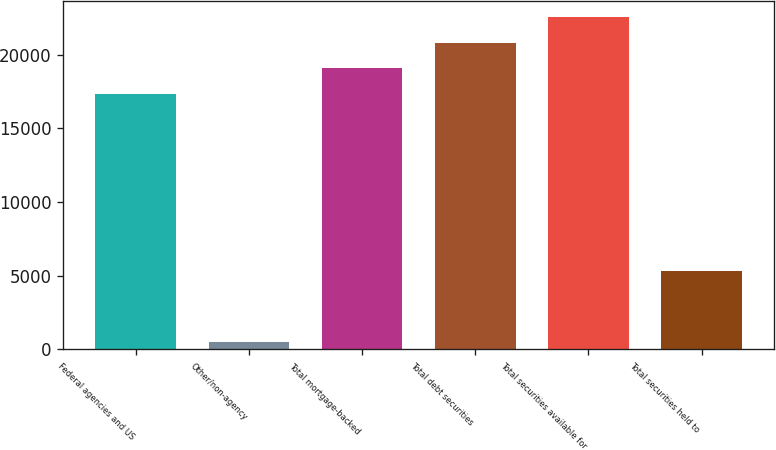Convert chart. <chart><loc_0><loc_0><loc_500><loc_500><bar_chart><fcel>Federal agencies and US<fcel>Other/non-agency<fcel>Total mortgage-backed<fcel>Total debt securities<fcel>Total securities available for<fcel>Total securities held to<nl><fcel>17320<fcel>522<fcel>19056.2<fcel>20792.4<fcel>22528.6<fcel>5297<nl></chart> 